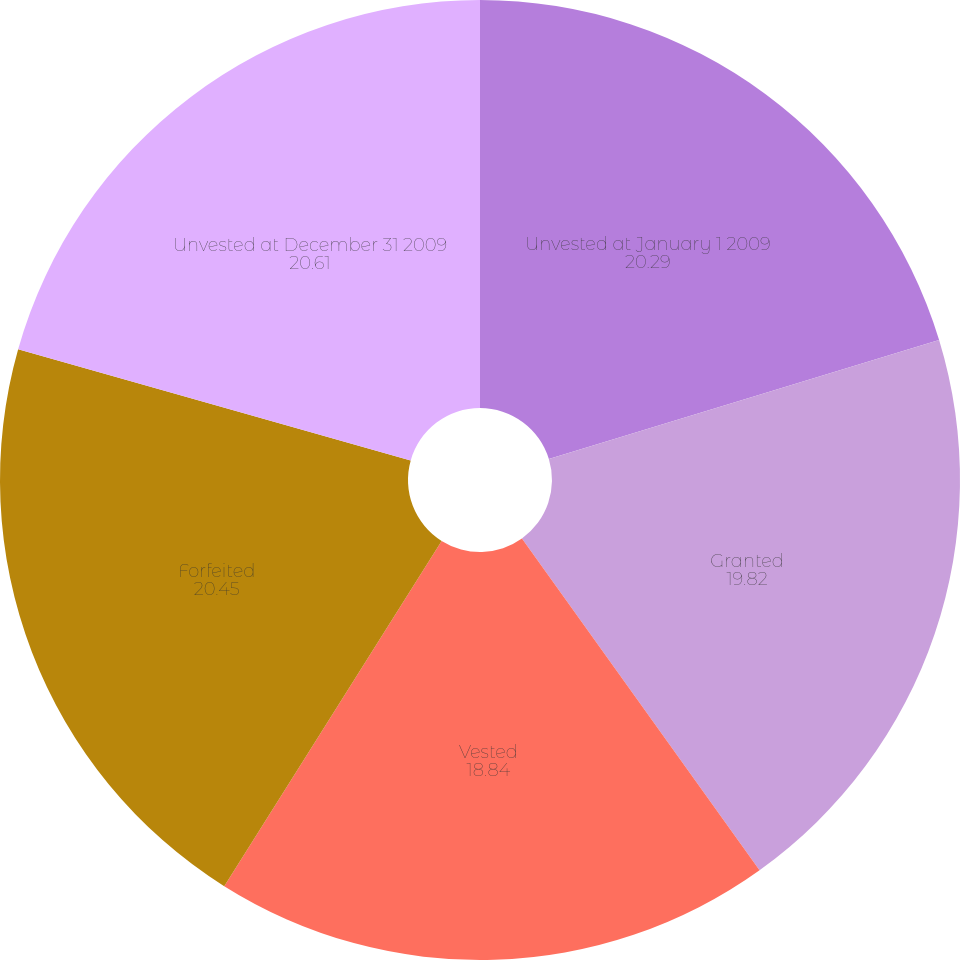<chart> <loc_0><loc_0><loc_500><loc_500><pie_chart><fcel>Unvested at January 1 2009<fcel>Granted<fcel>Vested<fcel>Forfeited<fcel>Unvested at December 31 2009<nl><fcel>20.29%<fcel>19.82%<fcel>18.84%<fcel>20.45%<fcel>20.61%<nl></chart> 